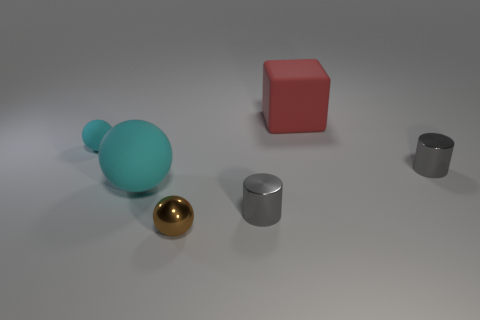What number of matte balls are right of the gray object that is in front of the big cyan ball?
Keep it short and to the point. 0. Are there any other things that have the same material as the small cyan sphere?
Make the answer very short. Yes. What number of things are rubber things in front of the red block or matte things?
Keep it short and to the point. 3. There is a object that is left of the large rubber ball; what is its size?
Offer a terse response. Small. What is the small brown object made of?
Your response must be concise. Metal. There is a gray metal object that is on the left side of the gray shiny thing right of the large matte block; what is its shape?
Offer a very short reply. Cylinder. How many other things are there of the same shape as the small brown object?
Your response must be concise. 2. There is a red block; are there any big red blocks to the left of it?
Keep it short and to the point. No. What color is the shiny sphere?
Your answer should be compact. Brown. Is the color of the small rubber sphere the same as the large matte thing that is behind the small cyan sphere?
Your response must be concise. No. 